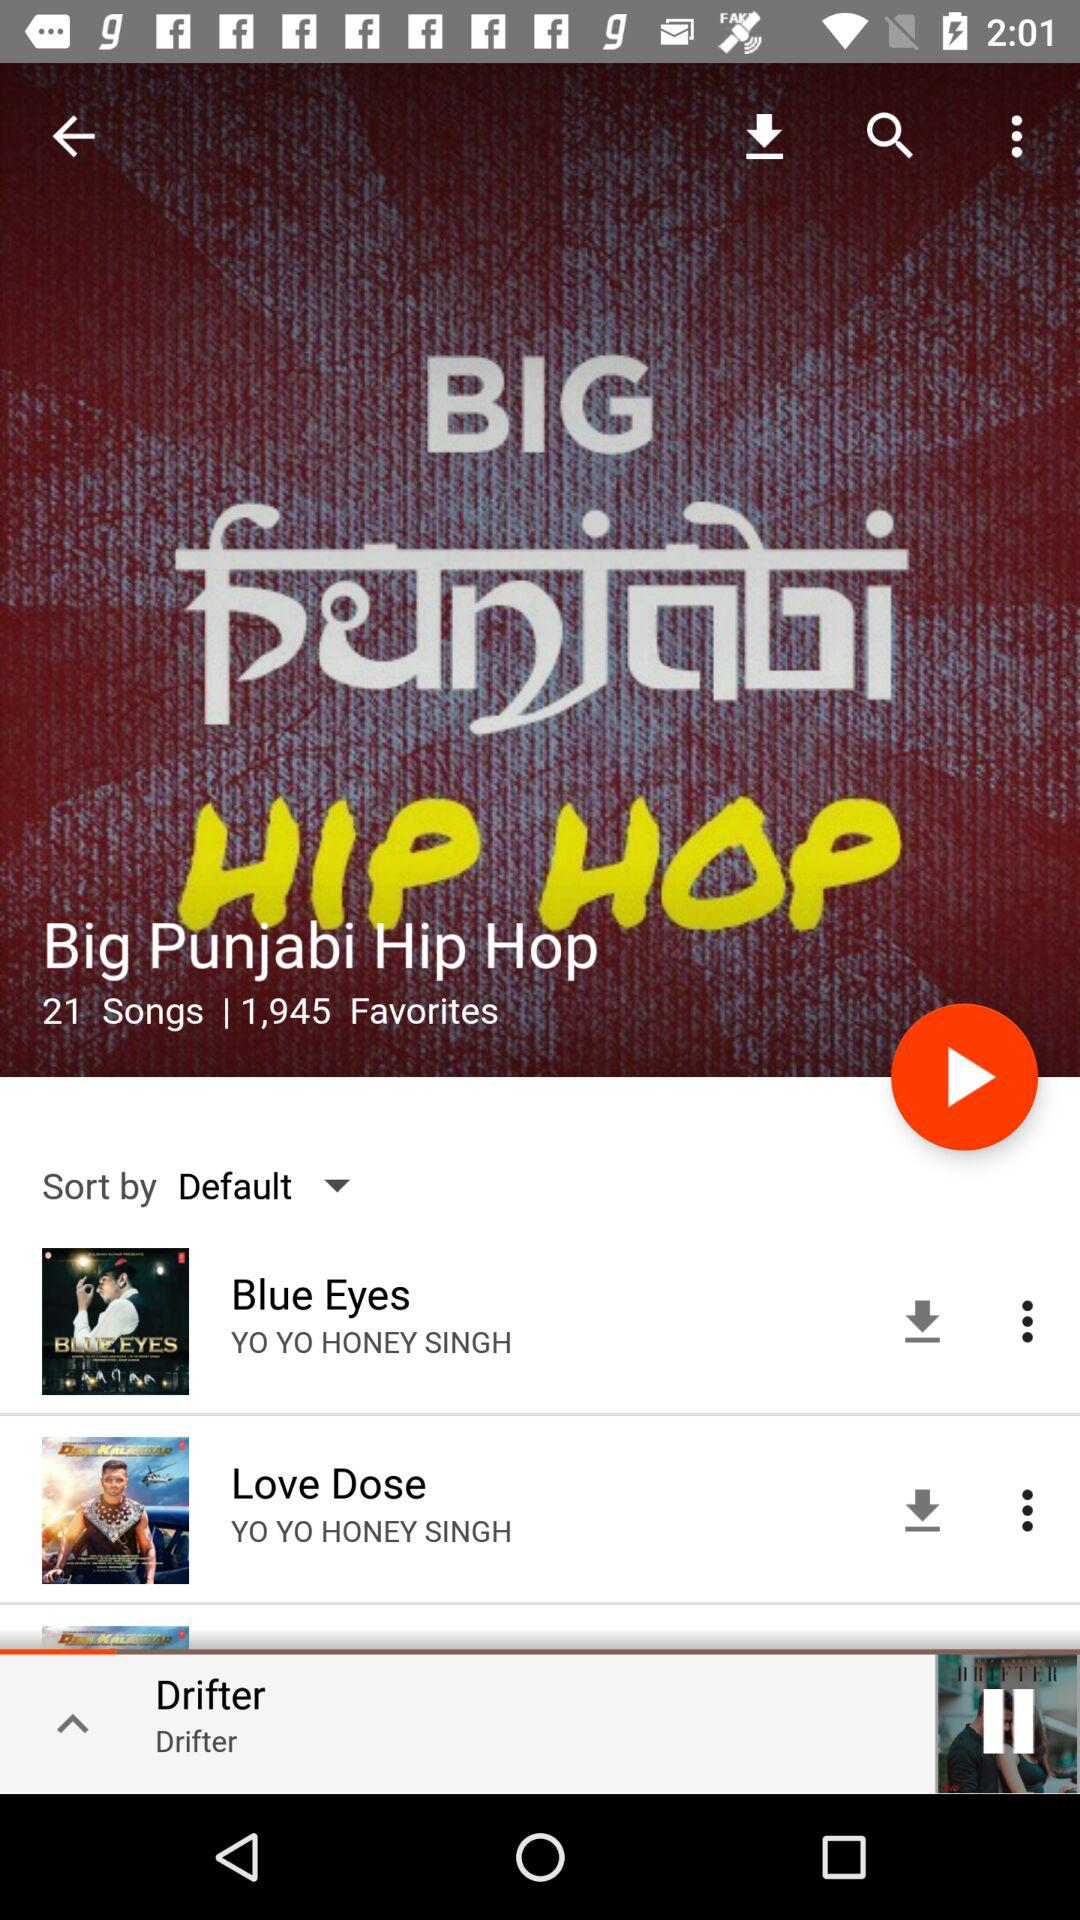How many songs are there in Big Punjabi Hip Hop? There are 21 songs in Big Punjabi Hip Hop. 